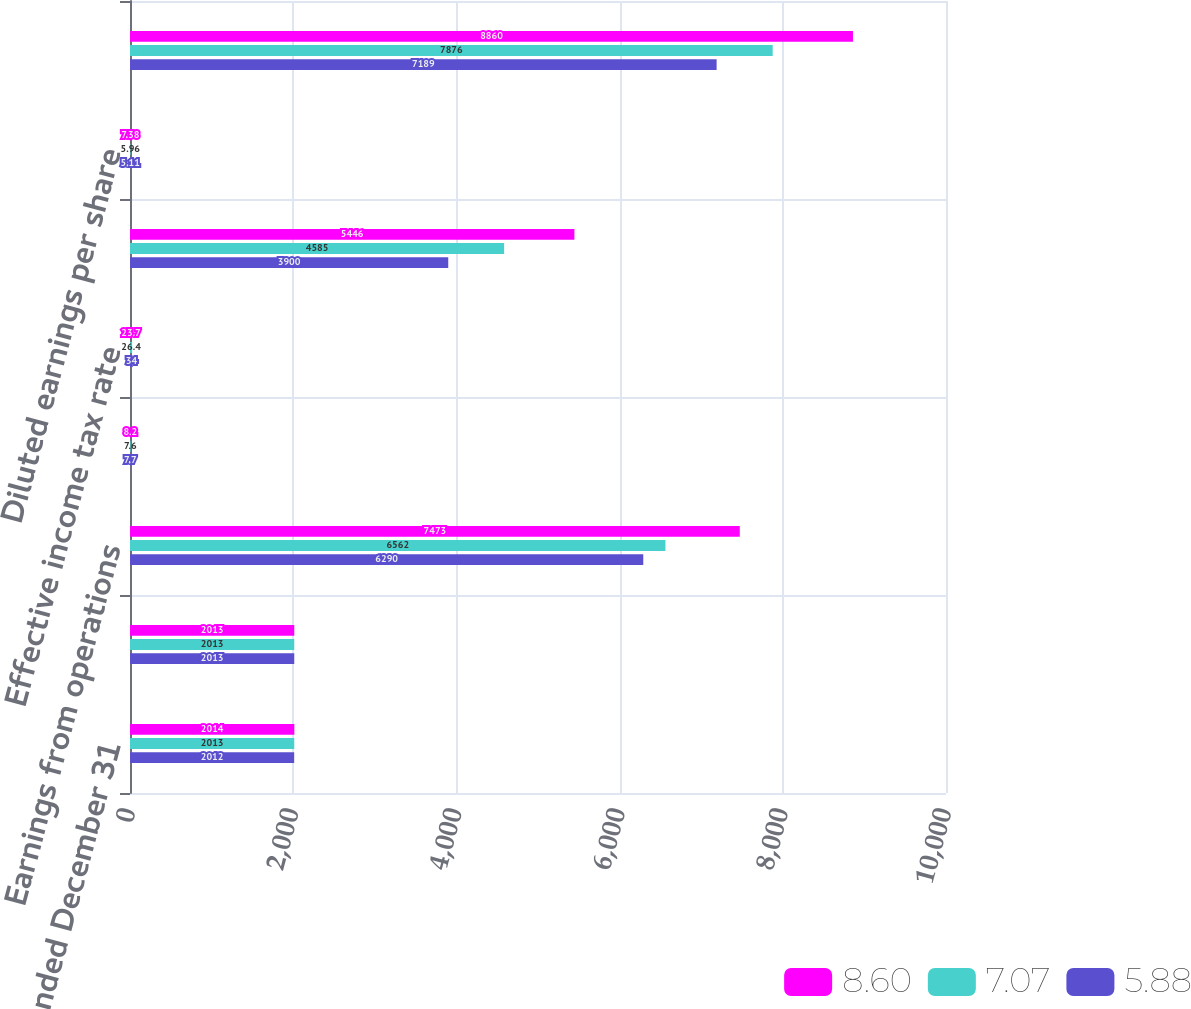<chart> <loc_0><loc_0><loc_500><loc_500><stacked_bar_chart><ecel><fcel>Years ended December 31<fcel>Revenues<fcel>Earnings from operations<fcel>Operating margins<fcel>Effective income tax rate<fcel>Net earnings<fcel>Diluted earnings per share<fcel>Core operating earnings<nl><fcel>8.6<fcel>2014<fcel>2013<fcel>7473<fcel>8.2<fcel>23.7<fcel>5446<fcel>7.38<fcel>8860<nl><fcel>7.07<fcel>2013<fcel>2013<fcel>6562<fcel>7.6<fcel>26.4<fcel>4585<fcel>5.96<fcel>7876<nl><fcel>5.88<fcel>2012<fcel>2013<fcel>6290<fcel>7.7<fcel>34<fcel>3900<fcel>5.11<fcel>7189<nl></chart> 